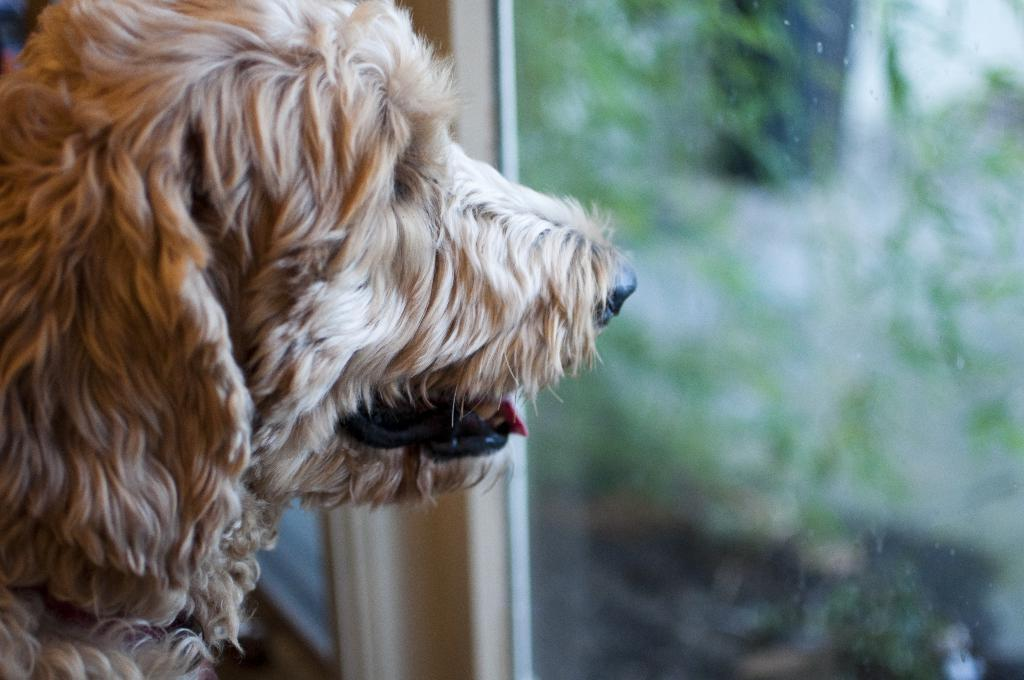What animal is present in the image? There is a dog in the image. What is the dog doing in the image? The dog is looking outside the window. What type of dinner is the dog smelling in the image? There is no dinner present in the image, and the dog is not shown smelling anything. What is the size of the dog in the image? The size of the dog cannot be determined from the image alone, as there is no reference point for comparison. 